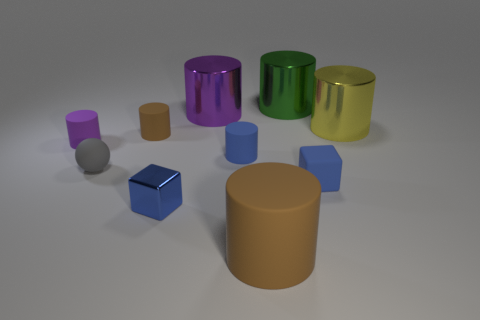Subtract all big green metallic cylinders. How many cylinders are left? 6 Subtract all gray spheres. How many blue cylinders are left? 1 Subtract all green cylinders. How many cylinders are left? 6 Subtract all balls. How many objects are left? 9 Subtract 1 blocks. How many blocks are left? 1 Subtract all red blocks. Subtract all red spheres. How many blocks are left? 2 Subtract all rubber cubes. Subtract all blue cylinders. How many objects are left? 8 Add 8 big purple metallic objects. How many big purple metallic objects are left? 9 Add 10 large matte blocks. How many large matte blocks exist? 10 Subtract 0 gray cylinders. How many objects are left? 10 